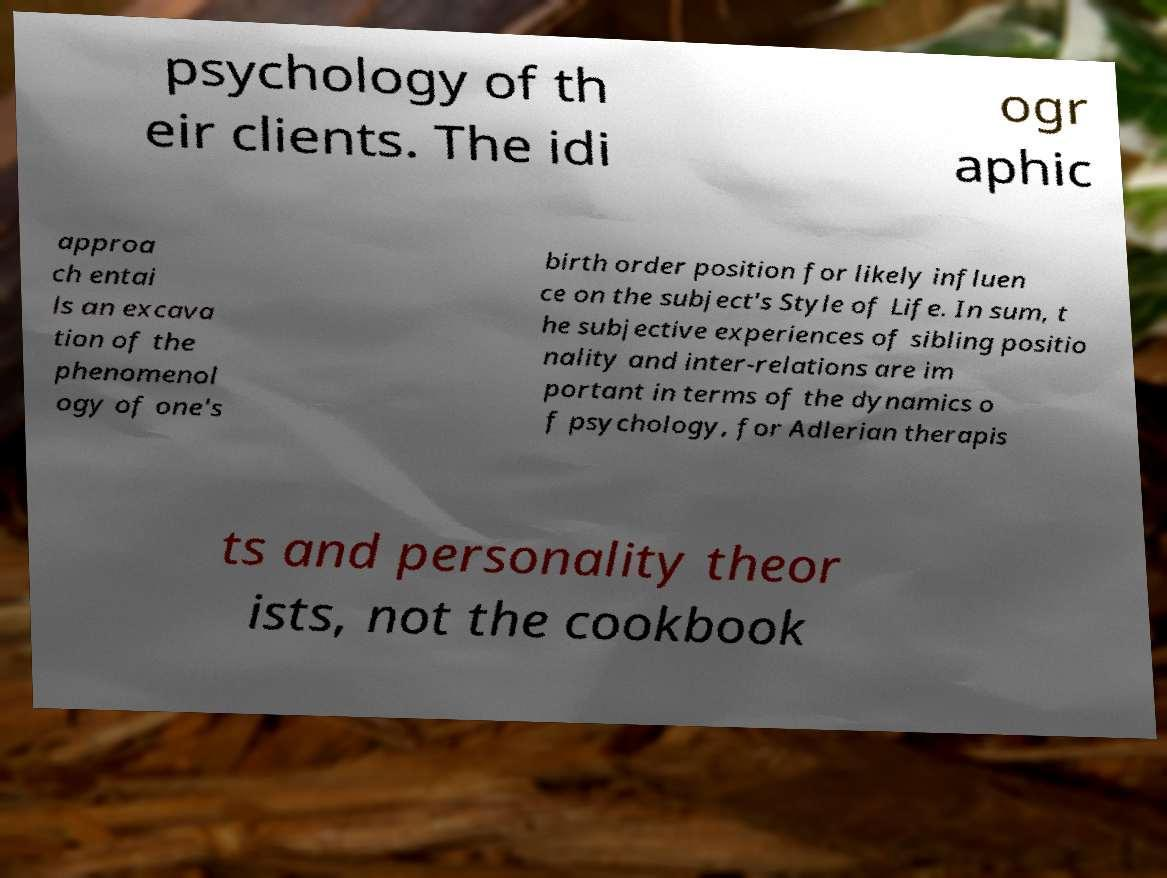For documentation purposes, I need the text within this image transcribed. Could you provide that? psychology of th eir clients. The idi ogr aphic approa ch entai ls an excava tion of the phenomenol ogy of one's birth order position for likely influen ce on the subject's Style of Life. In sum, t he subjective experiences of sibling positio nality and inter-relations are im portant in terms of the dynamics o f psychology, for Adlerian therapis ts and personality theor ists, not the cookbook 